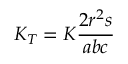Convert formula to latex. <formula><loc_0><loc_0><loc_500><loc_500>K _ { T } = K { \frac { 2 r ^ { 2 } s } { a b c } }</formula> 